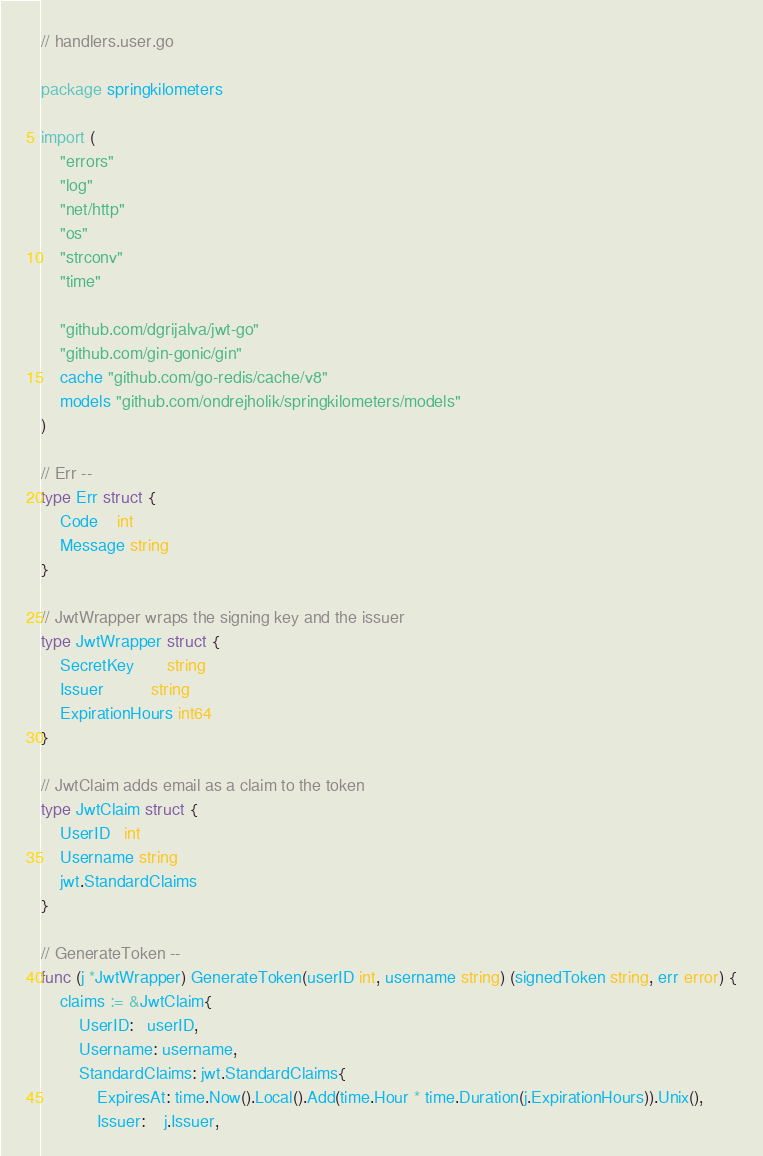<code> <loc_0><loc_0><loc_500><loc_500><_Go_>// handlers.user.go

package springkilometers

import (
	"errors"
	"log"
	"net/http"
	"os"
	"strconv"
	"time"

	"github.com/dgrijalva/jwt-go"
	"github.com/gin-gonic/gin"
	cache "github.com/go-redis/cache/v8"
	models "github.com/ondrejholik/springkilometers/models"
)

// Err --
type Err struct {
	Code    int
	Message string
}

// JwtWrapper wraps the signing key and the issuer
type JwtWrapper struct {
	SecretKey       string
	Issuer          string
	ExpirationHours int64
}

// JwtClaim adds email as a claim to the token
type JwtClaim struct {
	UserID   int
	Username string
	jwt.StandardClaims
}

// GenerateToken --
func (j *JwtWrapper) GenerateToken(userID int, username string) (signedToken string, err error) {
	claims := &JwtClaim{
		UserID:   userID,
		Username: username,
		StandardClaims: jwt.StandardClaims{
			ExpiresAt: time.Now().Local().Add(time.Hour * time.Duration(j.ExpirationHours)).Unix(),
			Issuer:    j.Issuer,</code> 